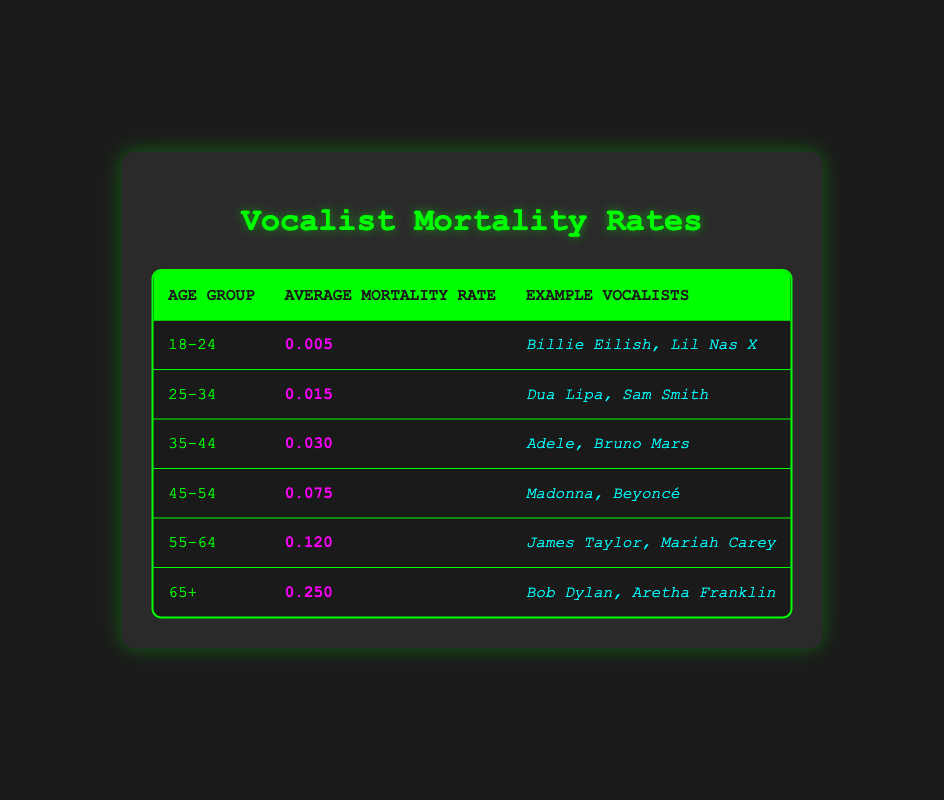What is the average mortality rate for vocalists aged 25-34? Referring to the table, the average mortality rate for the age group 25-34 is clearly listed as 0.015.
Answer: 0.015 Which age group has the highest average mortality rate? The last row of the table indicates that the age group 65+ has the highest average mortality rate at 0.250.
Answer: 65+ What are the example vocalists for the age group 45-54? The table shows that the example vocalists for the age group 45-54 are Madonna and Beyoncé.
Answer: Madonna, Beyoncé What is the total average mortality rate for all age groups listed? To find the total average mortality rate, we sum the average rates: 0.005 + 0.015 + 0.030 + 0.075 + 0.120 + 0.250 = 0.495. Then, divide by 6 (the number of age groups), resulting in an average of 0.495 / 6 = 0.0825.
Answer: 0.0825 Is it true that Adele falls within the age group with the highest average mortality rate? Adele is listed under the age group 35-44, which has a lower average mortality rate (0.030) compared to the age group 65+ (0.250). Therefore, it is false that Adele falls in the highest rate group.
Answer: No Which age group has an average mortality rate of 0.120? According to the table, the age group 55-64 is associated with an average mortality rate of 0.120.
Answer: 55-64 How many example vocalists are listed for the age group 18-24? The table shows there are two example vocalists for the age group 18-24, specifically Billie Eilish and Lil Nas X.
Answer: 2 What is the difference in average mortality rate between the age groups 45-54 and 35-44? The average mortality rate for the age group 45-54 is 0.075, while for the age group 35-44 it is 0.030. The difference is 0.075 - 0.030 = 0.045.
Answer: 0.045 